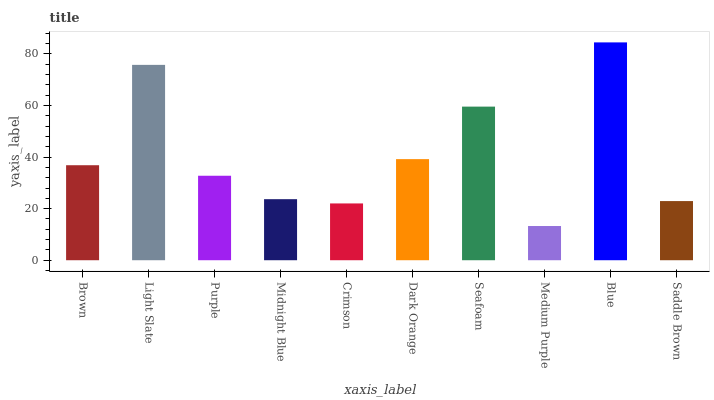Is Medium Purple the minimum?
Answer yes or no. Yes. Is Blue the maximum?
Answer yes or no. Yes. Is Light Slate the minimum?
Answer yes or no. No. Is Light Slate the maximum?
Answer yes or no. No. Is Light Slate greater than Brown?
Answer yes or no. Yes. Is Brown less than Light Slate?
Answer yes or no. Yes. Is Brown greater than Light Slate?
Answer yes or no. No. Is Light Slate less than Brown?
Answer yes or no. No. Is Brown the high median?
Answer yes or no. Yes. Is Purple the low median?
Answer yes or no. Yes. Is Dark Orange the high median?
Answer yes or no. No. Is Midnight Blue the low median?
Answer yes or no. No. 